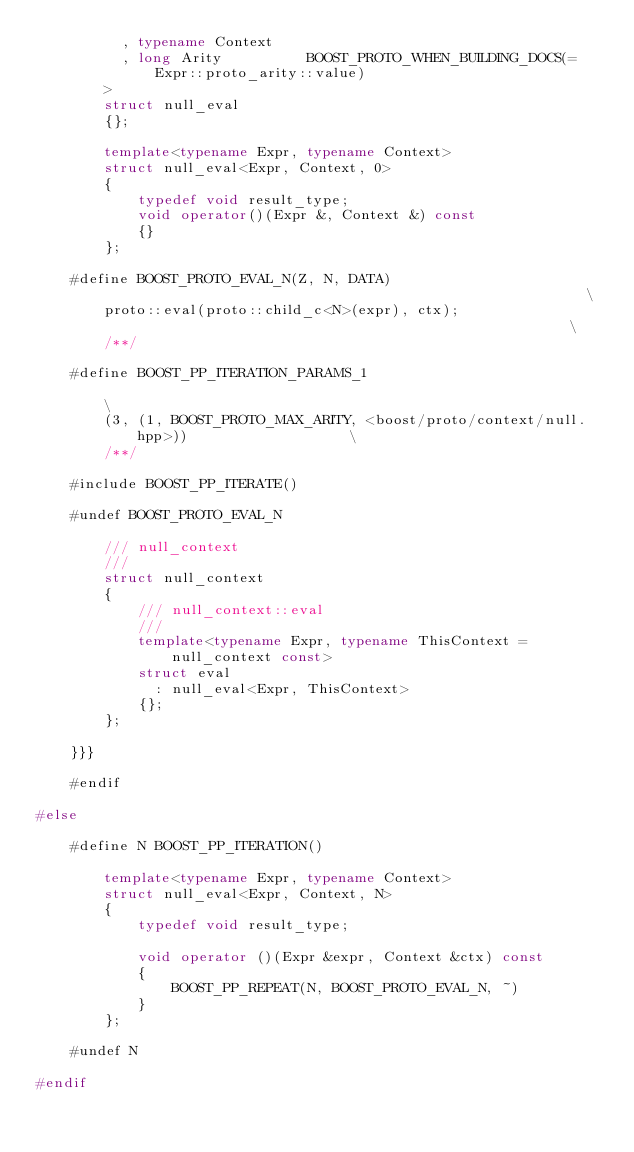Convert code to text. <code><loc_0><loc_0><loc_500><loc_500><_C++_>          , typename Context
          , long Arity          BOOST_PROTO_WHEN_BUILDING_DOCS(= Expr::proto_arity::value)
        >
        struct null_eval
        {};

        template<typename Expr, typename Context>
        struct null_eval<Expr, Context, 0>
        {
            typedef void result_type;
            void operator()(Expr &, Context &) const
            {}
        };

    #define BOOST_PROTO_EVAL_N(Z, N, DATA)                                                          \
        proto::eval(proto::child_c<N>(expr), ctx);                                                    \
        /**/

    #define BOOST_PP_ITERATION_PARAMS_1                                                             \
        (3, (1, BOOST_PROTO_MAX_ARITY, <boost/proto/context/null.hpp>))                   \
        /**/

    #include BOOST_PP_ITERATE()

    #undef BOOST_PROTO_EVAL_N

        /// null_context
        ///
        struct null_context
        {
            /// null_context::eval
            ///
            template<typename Expr, typename ThisContext = null_context const>
            struct eval
              : null_eval<Expr, ThisContext>
            {};
        };

    }}}

    #endif

#else

    #define N BOOST_PP_ITERATION()

        template<typename Expr, typename Context>
        struct null_eval<Expr, Context, N>
        {
            typedef void result_type;

            void operator ()(Expr &expr, Context &ctx) const
            {
                BOOST_PP_REPEAT(N, BOOST_PROTO_EVAL_N, ~)
            }
        };

    #undef N

#endif
</code> 